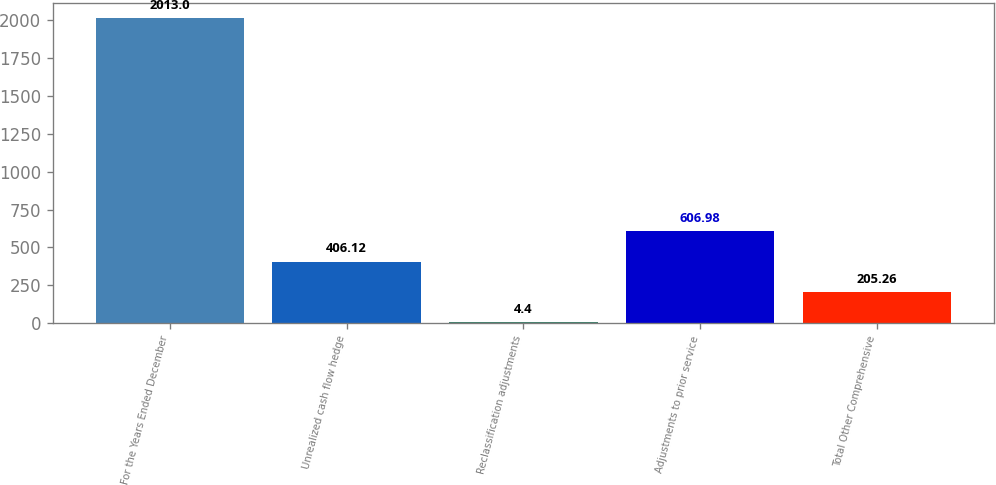Convert chart to OTSL. <chart><loc_0><loc_0><loc_500><loc_500><bar_chart><fcel>For the Years Ended December<fcel>Unrealized cash flow hedge<fcel>Reclassification adjustments<fcel>Adjustments to prior service<fcel>Total Other Comprehensive<nl><fcel>2013<fcel>406.12<fcel>4.4<fcel>606.98<fcel>205.26<nl></chart> 